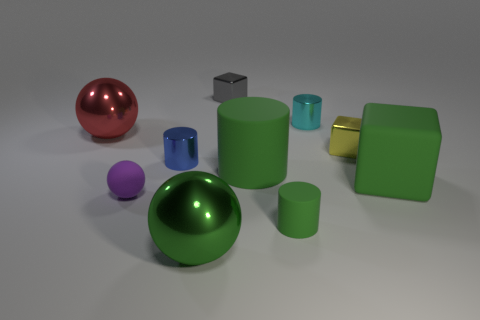Subtract all tiny metal cubes. How many cubes are left? 1 Subtract all blue cylinders. How many cylinders are left? 3 Subtract all spheres. How many objects are left? 7 Subtract 1 blocks. How many blocks are left? 2 Subtract all cyan cubes. Subtract all purple cylinders. How many cubes are left? 3 Subtract all purple spheres. How many red cylinders are left? 0 Subtract all green shiny objects. Subtract all large red things. How many objects are left? 8 Add 9 small matte balls. How many small matte balls are left? 10 Add 7 small rubber objects. How many small rubber objects exist? 9 Subtract 1 green spheres. How many objects are left? 9 